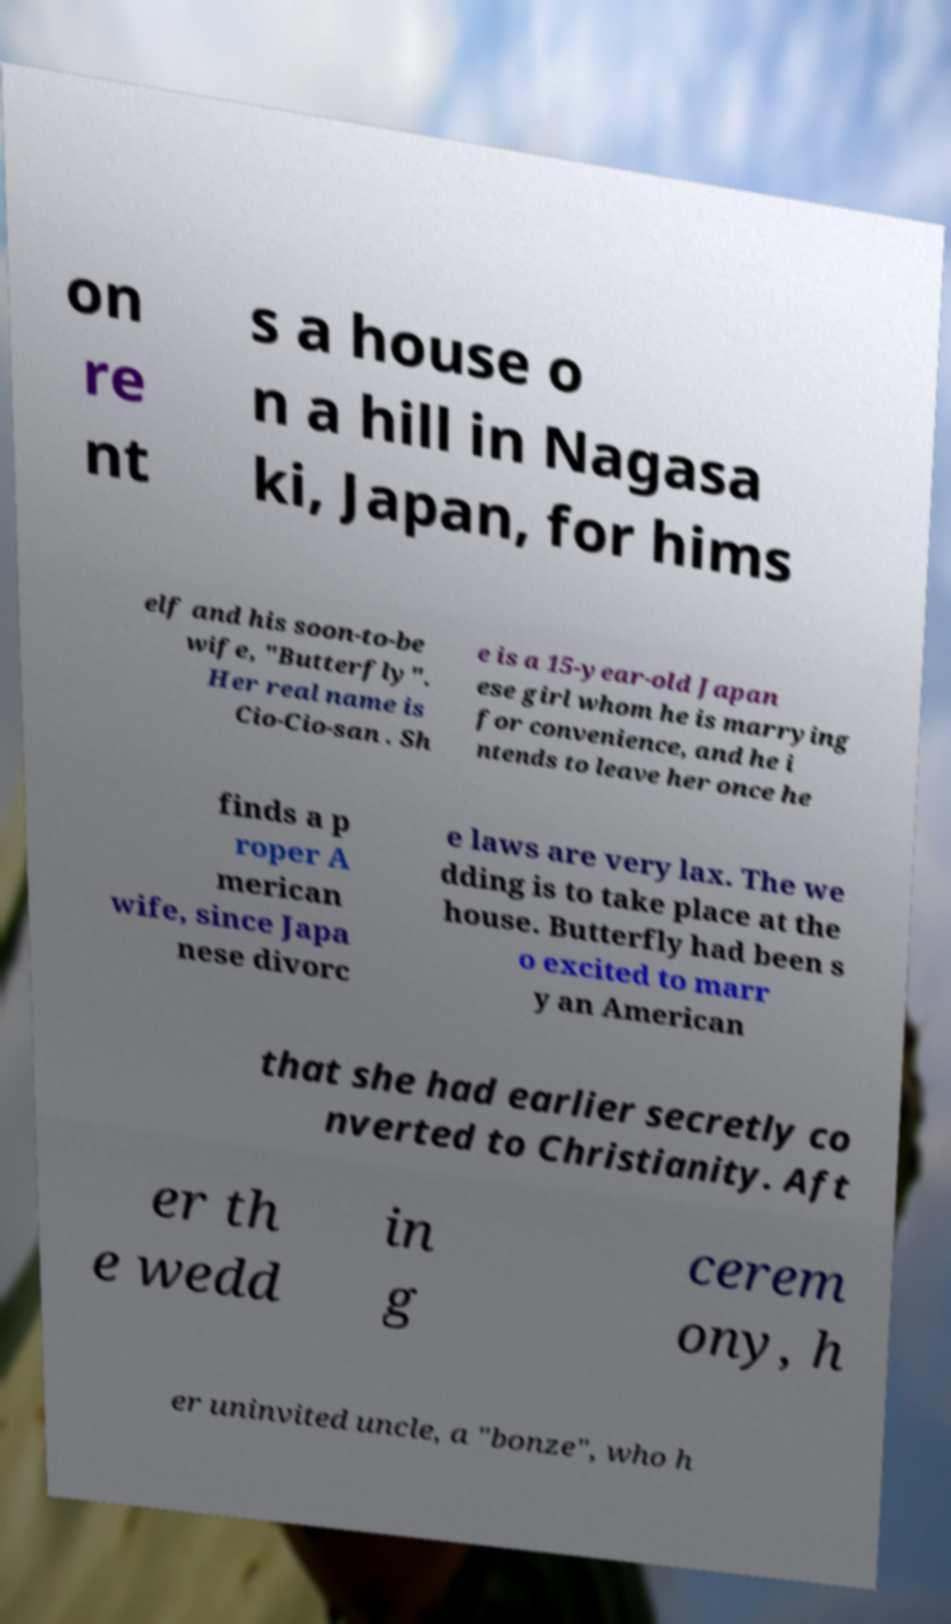Could you extract and type out the text from this image? on re nt s a house o n a hill in Nagasa ki, Japan, for hims elf and his soon-to-be wife, "Butterfly". Her real name is Cio-Cio-san . Sh e is a 15-year-old Japan ese girl whom he is marrying for convenience, and he i ntends to leave her once he finds a p roper A merican wife, since Japa nese divorc e laws are very lax. The we dding is to take place at the house. Butterfly had been s o excited to marr y an American that she had earlier secretly co nverted to Christianity. Aft er th e wedd in g cerem ony, h er uninvited uncle, a "bonze", who h 